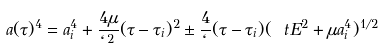Convert formula to latex. <formula><loc_0><loc_0><loc_500><loc_500>a ( \tau ) ^ { 4 } = a _ { i } ^ { 4 } + \frac { 4 \mu } { \ell ^ { 2 } } ( \tau - \tau _ { i } ) ^ { 2 } \pm \frac { 4 } { \ell } ( \tau - \tau _ { i } ) ( \ t E ^ { 2 } + \mu a _ { i } ^ { 4 } ) ^ { 1 / 2 }</formula> 